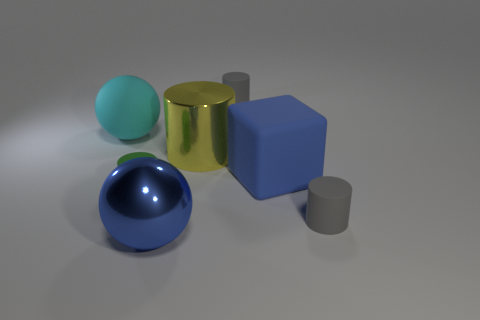Add 1 small gray objects. How many objects exist? 8 Subtract all cubes. How many objects are left? 6 Add 5 yellow shiny cylinders. How many yellow shiny cylinders exist? 6 Subtract 0 purple blocks. How many objects are left? 7 Subtract all cylinders. Subtract all blue balls. How many objects are left? 2 Add 5 large rubber cubes. How many large rubber cubes are left? 6 